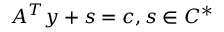<formula> <loc_0><loc_0><loc_500><loc_500>A ^ { T } y + s = c , s \in C ^ { * }</formula> 